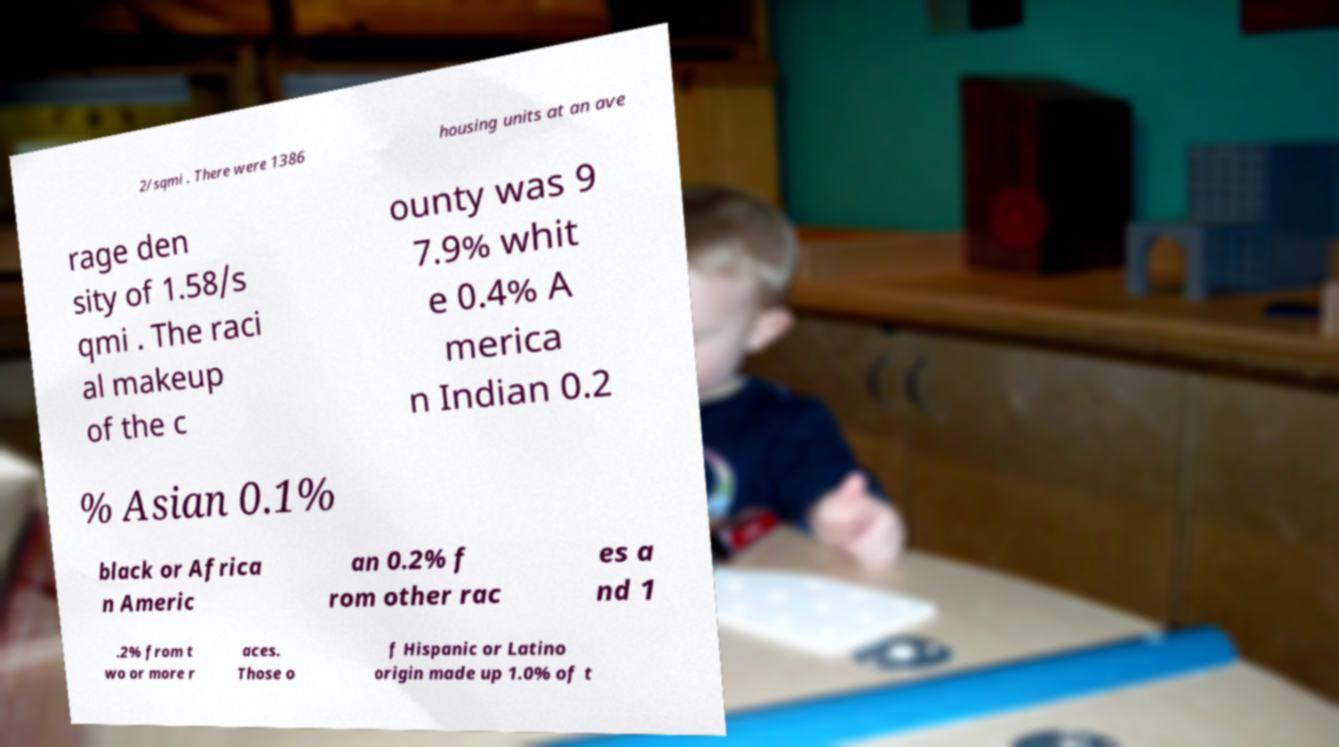Can you read and provide the text displayed in the image?This photo seems to have some interesting text. Can you extract and type it out for me? 2/sqmi . There were 1386 housing units at an ave rage den sity of 1.58/s qmi . The raci al makeup of the c ounty was 9 7.9% whit e 0.4% A merica n Indian 0.2 % Asian 0.1% black or Africa n Americ an 0.2% f rom other rac es a nd 1 .2% from t wo or more r aces. Those o f Hispanic or Latino origin made up 1.0% of t 